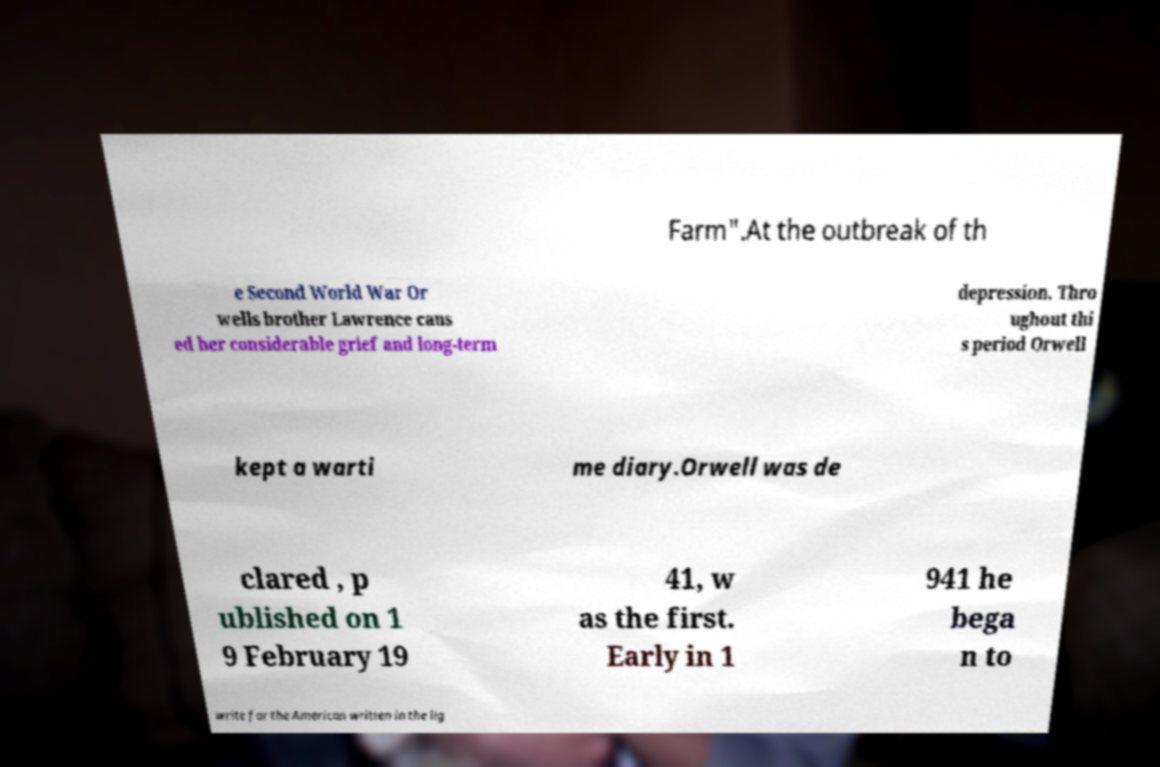For documentation purposes, I need the text within this image transcribed. Could you provide that? Farm".At the outbreak of th e Second World War Or wells brother Lawrence caus ed her considerable grief and long-term depression. Thro ughout thi s period Orwell kept a warti me diary.Orwell was de clared , p ublished on 1 9 February 19 41, w as the first. Early in 1 941 he bega n to write for the American written in the lig 